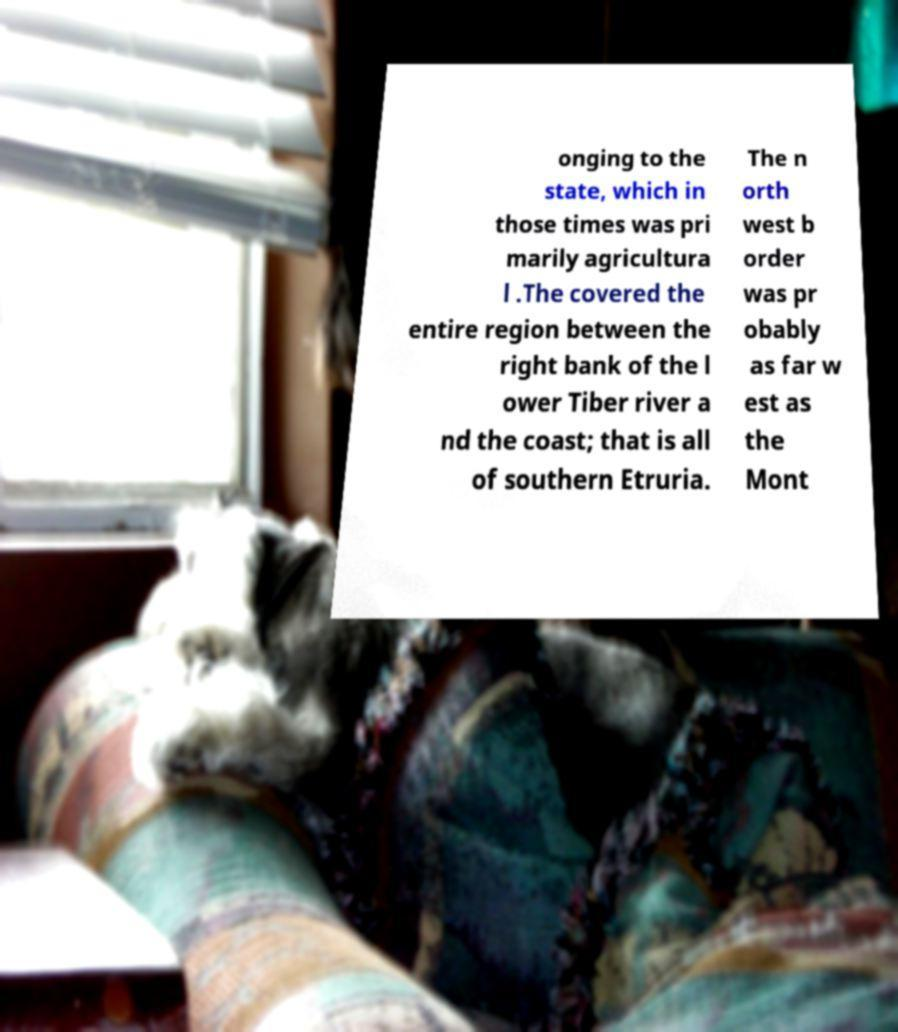Can you read and provide the text displayed in the image?This photo seems to have some interesting text. Can you extract and type it out for me? onging to the state, which in those times was pri marily agricultura l .The covered the entire region between the right bank of the l ower Tiber river a nd the coast; that is all of southern Etruria. The n orth west b order was pr obably as far w est as the Mont 